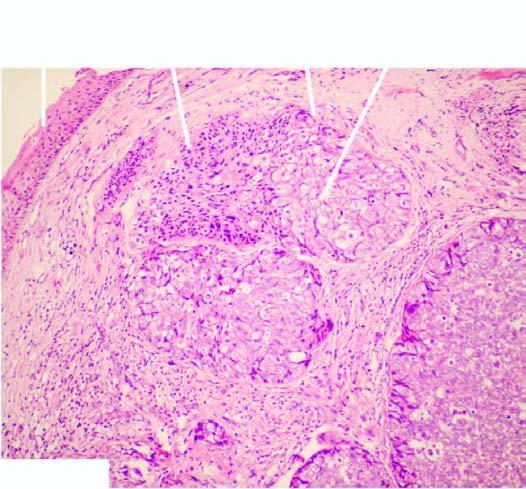do the cells have sebaceous differentiation appreciated by foamy, vacuolated cytoplasm?
Answer the question using a single word or phrase. Yes 